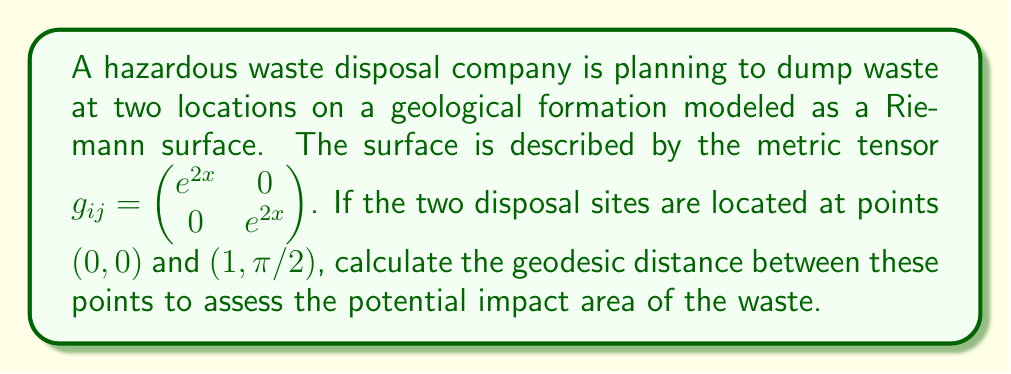What is the answer to this math problem? To calculate the geodesic distance between two points on a Riemann surface, we need to use the following steps:

1. Identify the metric tensor: $g_{ij} = \begin{pmatrix} e^{2x} & 0 \\ 0 & e^{2x} \end{pmatrix}$

2. Set up the line element: $ds^2 = e^{2x}dx^2 + e^{2x}dy^2$

3. Use the geodesic equation: $\frac{d^2x^i}{dt^2} + \Gamma^i_{jk}\frac{dx^j}{dt}\frac{dx^k}{dt} = 0$, where $\Gamma^i_{jk}$ are the Christoffel symbols.

4. Calculate the Christoffel symbols:
   $\Gamma^1_{11} = 1, \Gamma^1_{22} = -e^{2x}, \Gamma^2_{12} = \Gamma^2_{21} = 1$
   All other symbols are zero.

5. Solve the geodesic equations:
   $\frac{d^2x}{dt^2} + (\frac{dx}{dt})^2 - e^{2x}(\frac{dy}{dt})^2 = 0$
   $\frac{d^2y}{dt^2} + 2\frac{dx}{dt}\frac{dy}{dt} = 0$

6. Due to the complexity of these equations, we'll use a simplifying assumption that the geodesic is a straight line in the $(x,y)$ plane:
   $y = \frac{\pi}{2}x$

7. Substitute this into the line element:
   $ds^2 = e^{2x}(dx^2 + (\frac{\pi}{2})^2dx^2) = e^{2x}(1 + (\frac{\pi}{2})^2)dx^2$

8. Integrate to find the geodesic distance:
   $L = \int_0^1 \sqrt{e^{2x}(1 + (\frac{\pi}{2})^2)} dx$

9. Evaluate the integral:
   $L = \sqrt{1 + (\frac{\pi}{2})^2} \int_0^1 e^x dx = \sqrt{1 + (\frac{\pi}{2})^2} (e - 1)$

10. Simplify:
    $L = \sqrt{1 + \frac{\pi^2}{4}} (e - 1) \approx 3.76$
Answer: $\sqrt{1 + \frac{\pi^2}{4}} (e - 1)$ units 